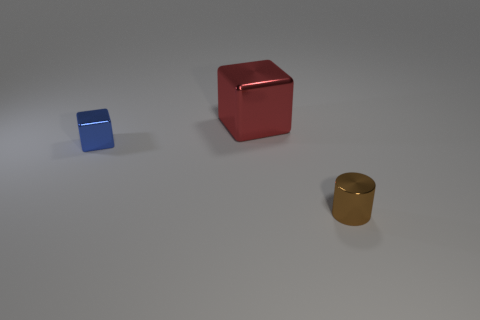How many things are small objects behind the small cylinder or purple metallic things?
Ensure brevity in your answer.  1. There is a red object that is behind the blue shiny block; how big is it?
Give a very brief answer. Large. There is a brown cylinder; is its size the same as the block that is on the left side of the large metallic object?
Make the answer very short. Yes. The small metallic object that is behind the tiny thing that is right of the big shiny object is what color?
Offer a terse response. Blue. What number of other things are there of the same color as the large shiny thing?
Provide a short and direct response. 0. How big is the brown shiny thing?
Ensure brevity in your answer.  Small. Are there more blocks that are right of the blue metal cube than brown metal cylinders behind the brown thing?
Offer a very short reply. Yes. There is a small thing behind the small brown shiny thing; what number of blue shiny objects are to the left of it?
Ensure brevity in your answer.  0. There is a tiny thing left of the red metal block; does it have the same shape as the big red thing?
Ensure brevity in your answer.  Yes. How many blue things are the same size as the red thing?
Provide a succinct answer. 0. 